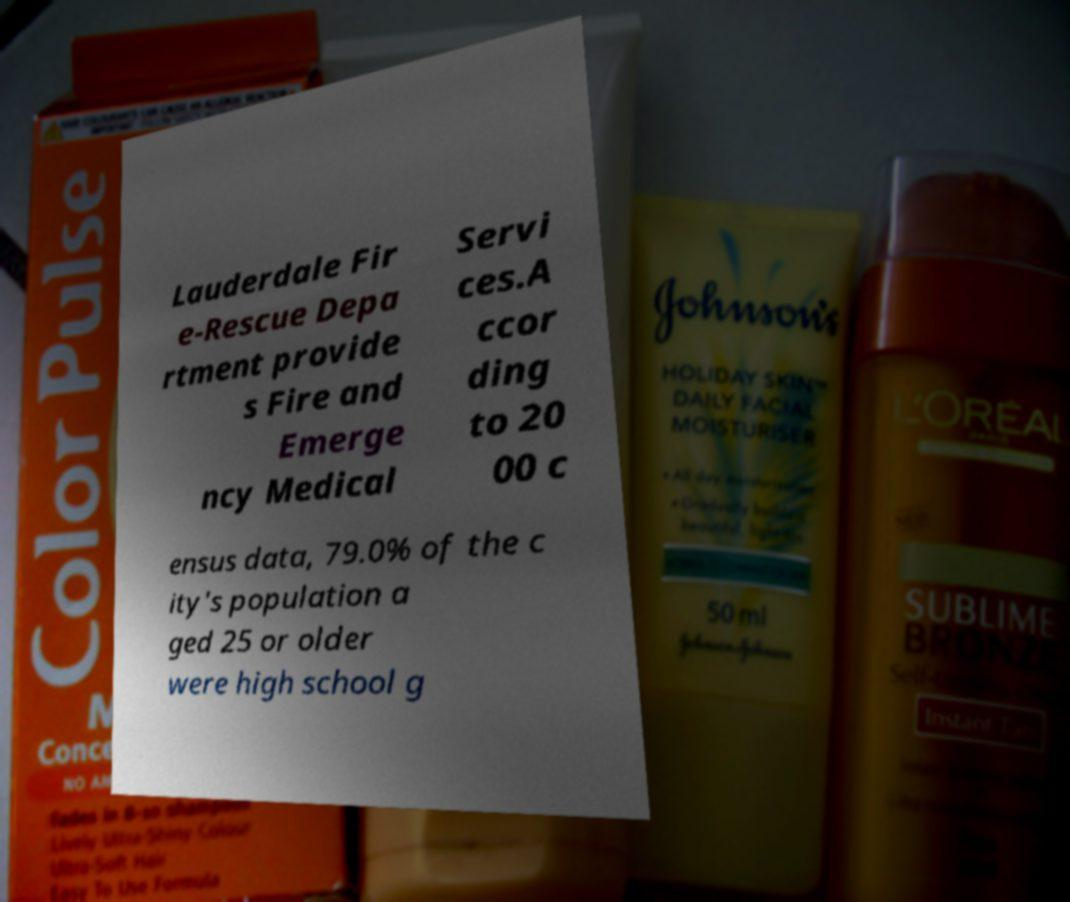There's text embedded in this image that I need extracted. Can you transcribe it verbatim? Lauderdale Fir e-Rescue Depa rtment provide s Fire and Emerge ncy Medical Servi ces.A ccor ding to 20 00 c ensus data, 79.0% of the c ity's population a ged 25 or older were high school g 